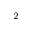<formula> <loc_0><loc_0><loc_500><loc_500>^ { 2 }</formula> 